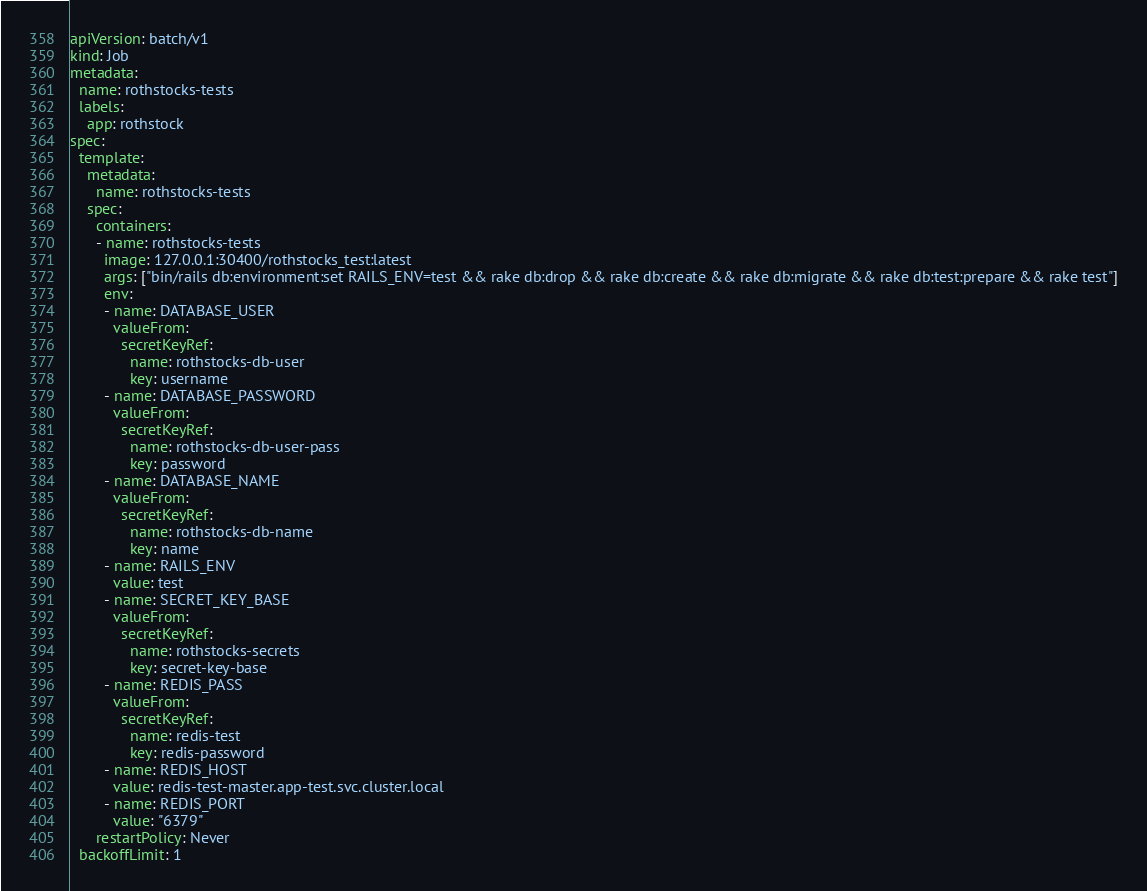Convert code to text. <code><loc_0><loc_0><loc_500><loc_500><_YAML_>apiVersion: batch/v1
kind: Job
metadata:
  name: rothstocks-tests
  labels:
    app: rothstock
spec:
  template:
    metadata:
      name: rothstocks-tests
    spec:
      containers:
      - name: rothstocks-tests
        image: 127.0.0.1:30400/rothstocks_test:latest
        args: ["bin/rails db:environment:set RAILS_ENV=test && rake db:drop && rake db:create && rake db:migrate && rake db:test:prepare && rake test"]
        env:
        - name: DATABASE_USER
          valueFrom:
            secretKeyRef:
              name: rothstocks-db-user
              key: username
        - name: DATABASE_PASSWORD
          valueFrom:
            secretKeyRef:
              name: rothstocks-db-user-pass
              key: password
        - name: DATABASE_NAME
          valueFrom:
            secretKeyRef:
              name: rothstocks-db-name
              key: name
        - name: RAILS_ENV
          value: test
        - name: SECRET_KEY_BASE
          valueFrom:
            secretKeyRef:
              name: rothstocks-secrets
              key: secret-key-base          
        - name: REDIS_PASS
          valueFrom:
            secretKeyRef:
              name: redis-test
              key: redis-password
        - name: REDIS_HOST
          value: redis-test-master.app-test.svc.cluster.local
        - name: REDIS_PORT
          value: "6379"
      restartPolicy: Never
  backoffLimit: 1

</code> 